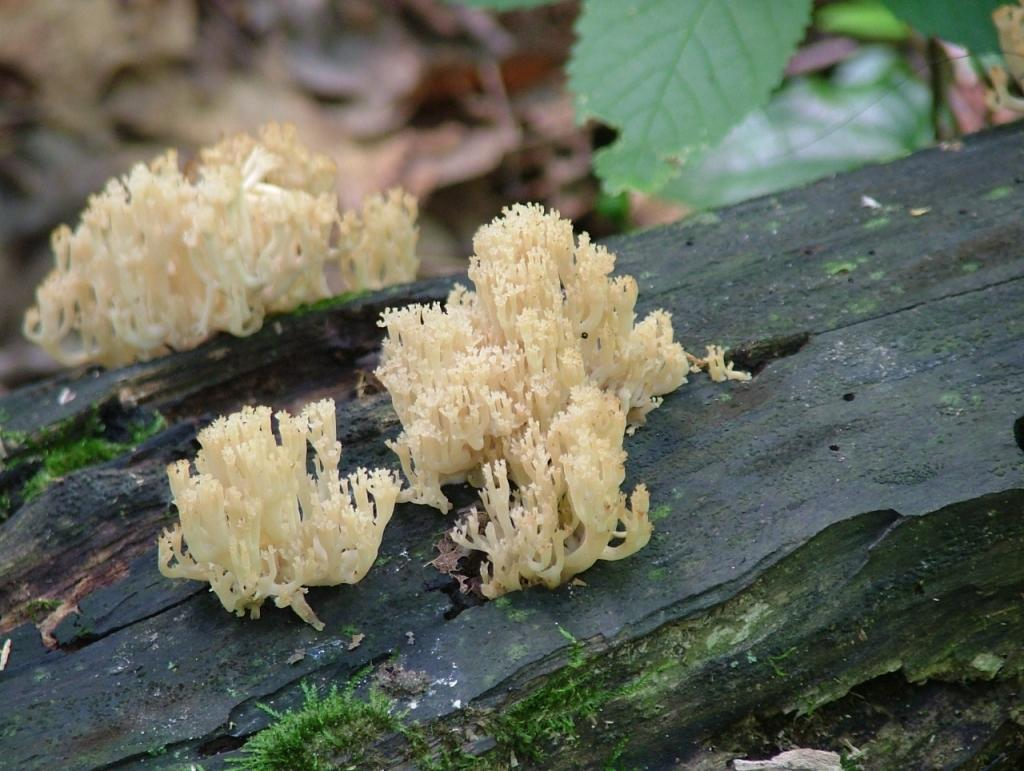What type of organism can be seen on the wooden bark in the image? There is fungus on the wooden bark in the image. What can be seen in the background of the image? There are plants visible in the background of the image. What type of apparatus is being used to store the fungus in the image? There is no apparatus present in the image; the fungus is growing on the wooden bark. Can you recall any memories associated with the fungus in the image? The image does not contain any information about personal memories, as it is a photograph of fungus on wooden bark. 